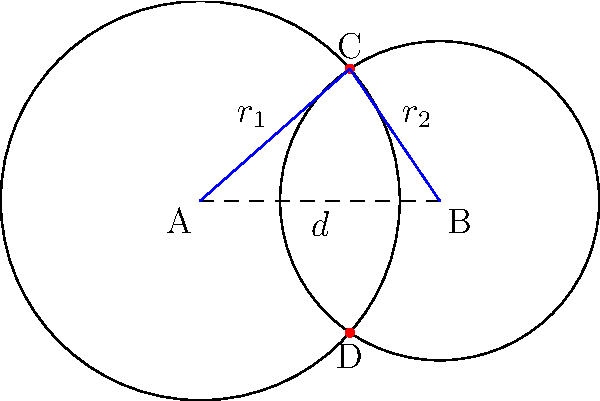Two circular mining shafts are being drilled into a volcanic rock formation. The centers of these shafts, A and B, are 3 units apart. The radius of shaft A is 2.5 units, and the radius of shaft B is 2 units. The shafts intersect at points C and D. Calculate the area of the quadrilateral ACBD formed by connecting the centers of the shafts to their intersection points. Let's approach this step-by-step:

1) First, we need to find the angle CAB. We can do this using the cosine law:

   $$\cos(CAB) = \frac{r_1^2 + d^2 - r_2^2}{2r_1d}$$

   Where $r_1 = 2.5$, $r_2 = 2$, and $d = 3$.

2) Plugging in the values:

   $$\cos(CAB) = \frac{2.5^2 + 3^2 - 2^2}{2(2.5)(3)} = \frac{10.25}{15} = 0.6833$$

3) Taking the inverse cosine:

   $$CAB = \arccos(0.6833) = 0.8112 \text{ radians}$$

4) The area of triangle CAB is:

   $$Area_{CAB} = \frac{1}{2}r_1d\sin(CAB) = \frac{1}{2}(2.5)(3)\sin(0.8112) = 1.8758$$

5) Similarly, we can find the angle CBA:

   $$\cos(CBA) = \frac{r_2^2 + d^2 - r_1^2}{2r_2d} = \frac{4 + 9 - 6.25}{12} = 0.5625$$

   $$CBA = \arccos(0.5625) = 0.9828 \text{ radians}$$

6) The area of triangle CBA is:

   $$Area_{CBA} = \frac{1}{2}r_2d\sin(CBA) = \frac{1}{2}(2)(3)\sin(0.9828) = 1.4142$$

7) The total area of quadrilateral ACBD is twice the sum of these areas:

   $$Area_{ACBD} = 2(Area_{CAB} + Area_{CBA}) = 2(1.8758 + 1.4142) = 6.5800$$

Therefore, the area of quadrilateral ACBD is approximately 6.58 square units.
Answer: 6.58 square units 